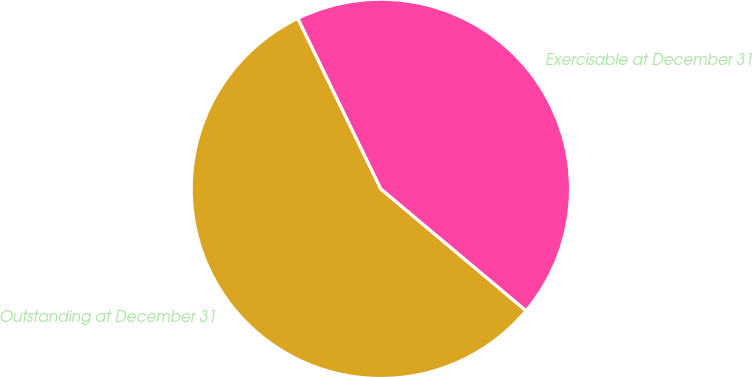Convert chart. <chart><loc_0><loc_0><loc_500><loc_500><pie_chart><fcel>Outstanding at December 31<fcel>Exercisable at December 31<nl><fcel>56.68%<fcel>43.32%<nl></chart> 